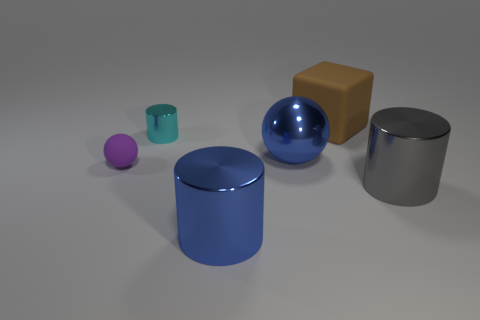Subtract all purple cylinders. Subtract all brown blocks. How many cylinders are left? 3 Add 2 small gray metal cylinders. How many objects exist? 8 Subtract all cubes. How many objects are left? 5 Add 6 gray metallic cylinders. How many gray metallic cylinders are left? 7 Add 1 blue metal cylinders. How many blue metal cylinders exist? 2 Subtract 0 blue blocks. How many objects are left? 6 Subtract all cyan cylinders. Subtract all tiny red rubber balls. How many objects are left? 5 